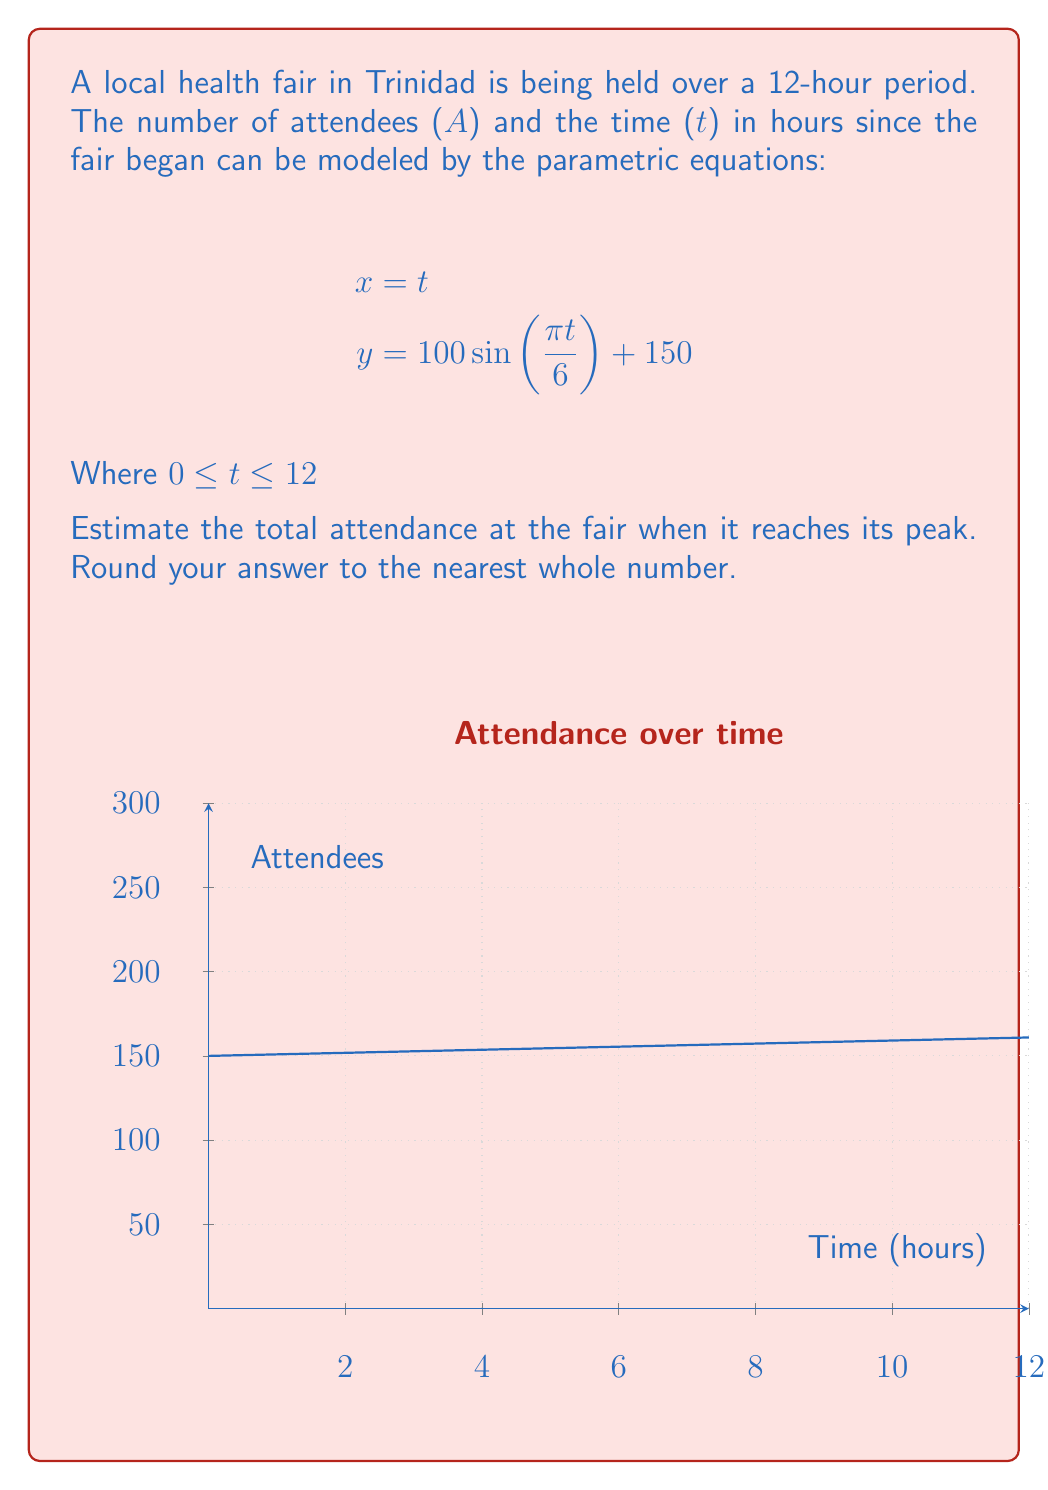Help me with this question. To solve this problem, we need to follow these steps:

1) The peak attendance will occur when the sine function reaches its maximum value of 1.

2) In the equation $y = 100\sin(\frac{\pi t}{6}) + 150$, the sine function will reach its maximum when:

   $$\frac{\pi t}{6} = \frac{\pi}{2}$$

3) Solving for t:
   $$t = \frac{6}{2} = 3$$

4) This means the peak occurs 3 hours after the fair begins.

5) To find the number of attendees at the peak, we substitute t = 3 into the equation for y:

   $$y = 100\sin(\frac{\pi (3)}{6}) + 150$$
   $$y = 100\sin(\frac{\pi}{2}) + 150$$
   $$y = 100(1) + 150$$
   $$y = 250$$

6) Therefore, the peak attendance is 250 people.
Answer: 250 attendees 